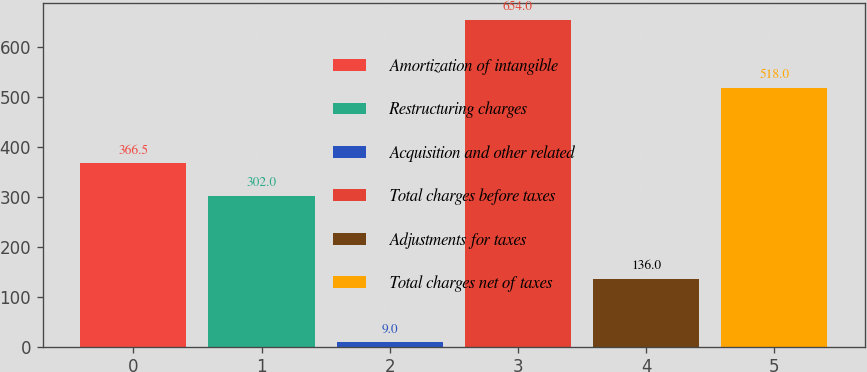Convert chart to OTSL. <chart><loc_0><loc_0><loc_500><loc_500><bar_chart><fcel>Amortization of intangible<fcel>Restructuring charges<fcel>Acquisition and other related<fcel>Total charges before taxes<fcel>Adjustments for taxes<fcel>Total charges net of taxes<nl><fcel>366.5<fcel>302<fcel>9<fcel>654<fcel>136<fcel>518<nl></chart> 